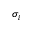Convert formula to latex. <formula><loc_0><loc_0><loc_500><loc_500>\sigma _ { i }</formula> 